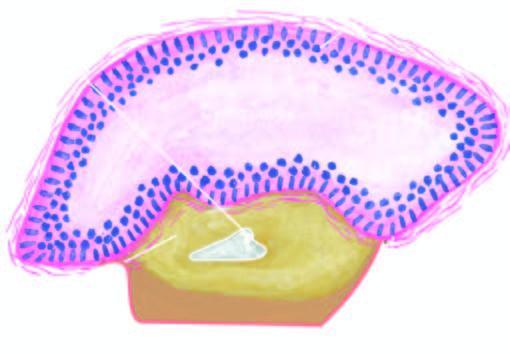what is also seen in the wall?
Answer the question using a single word or phrase. A partly formed unerupted tooth 